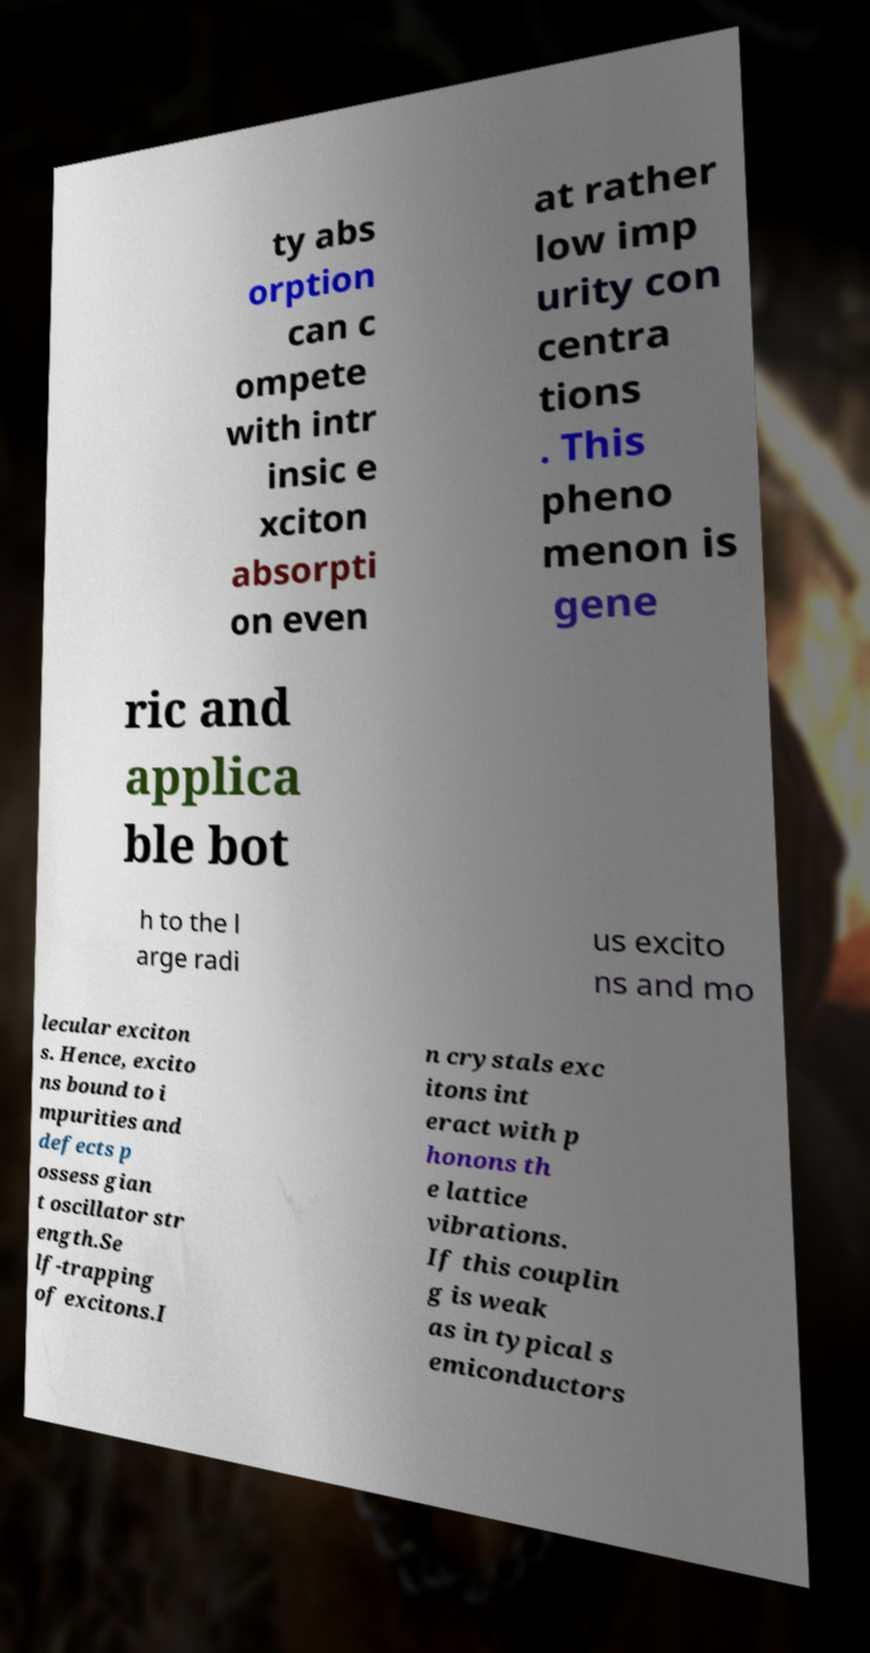Can you read and provide the text displayed in the image?This photo seems to have some interesting text. Can you extract and type it out for me? ty abs orption can c ompete with intr insic e xciton absorpti on even at rather low imp urity con centra tions . This pheno menon is gene ric and applica ble bot h to the l arge radi us excito ns and mo lecular exciton s. Hence, excito ns bound to i mpurities and defects p ossess gian t oscillator str ength.Se lf-trapping of excitons.I n crystals exc itons int eract with p honons th e lattice vibrations. If this couplin g is weak as in typical s emiconductors 